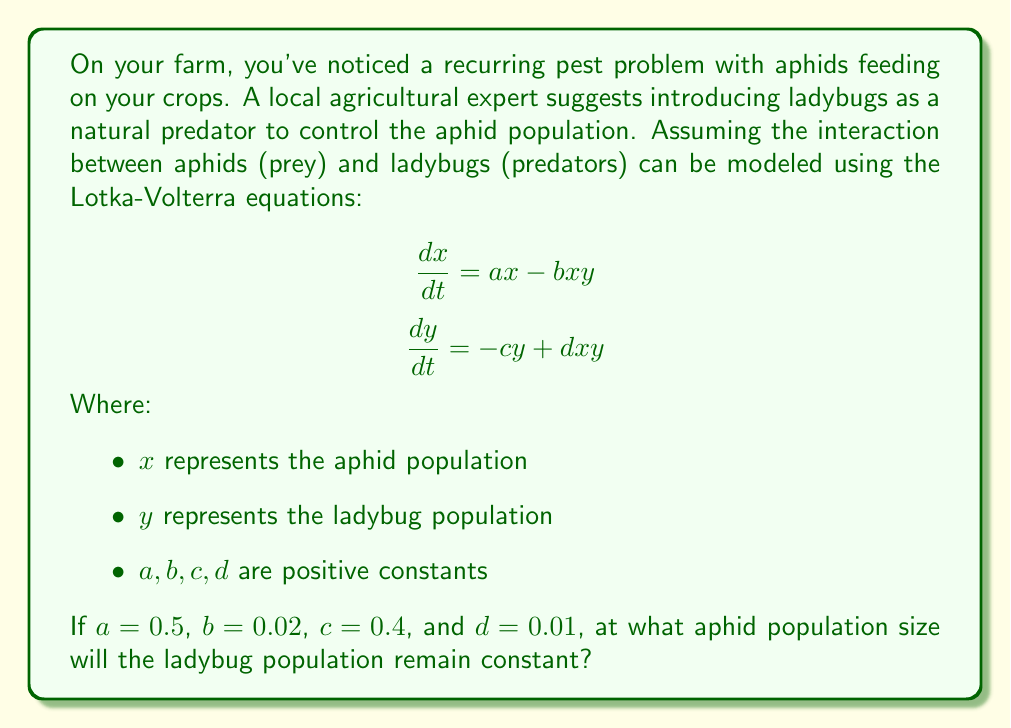Give your solution to this math problem. Let's approach this step-by-step:

1) For the ladybug population to remain constant, its rate of change should be zero. This means:

   $$\frac{dy}{dt} = 0$$

2) Substituting this into the second Lotka-Volterra equation:

   $$0 = -cy + dxy$$

3) Now, let's substitute the given values:

   $$0 = -0.4y + 0.01xy$$

4) We can factor out $y$ from this equation:

   $$0 = y(-0.4 + 0.01x)$$

5) For this equation to be true, either $y = 0$ (which isn't interesting for our problem) or:

   $$-0.4 + 0.01x = 0$$

6) Solving for $x$:

   $$0.01x = 0.4$$
   $$x = \frac{0.4}{0.01} = 40$$

This means that when the aphid population reaches 40, the ladybug population will remain constant.

To verify, we can check that this satisfies the original equation:

$$\frac{dy}{dt} = -0.4y + 0.01(40)y = -0.4y + 0.4y = 0$$

Indeed, when $x = 40$, the rate of change of the ladybug population is zero, regardless of the current ladybug population size.
Answer: The ladybug population will remain constant when the aphid population reaches 40. 